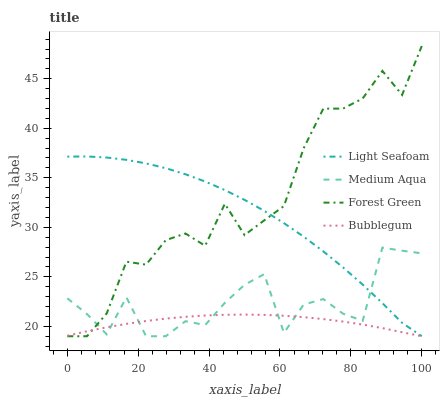Does Bubblegum have the minimum area under the curve?
Answer yes or no. Yes. Does Forest Green have the maximum area under the curve?
Answer yes or no. Yes. Does Light Seafoam have the minimum area under the curve?
Answer yes or no. No. Does Light Seafoam have the maximum area under the curve?
Answer yes or no. No. Is Bubblegum the smoothest?
Answer yes or no. Yes. Is Medium Aqua the roughest?
Answer yes or no. Yes. Is Light Seafoam the smoothest?
Answer yes or no. No. Is Light Seafoam the roughest?
Answer yes or no. No. Does Forest Green have the highest value?
Answer yes or no. Yes. Does Light Seafoam have the highest value?
Answer yes or no. No. 